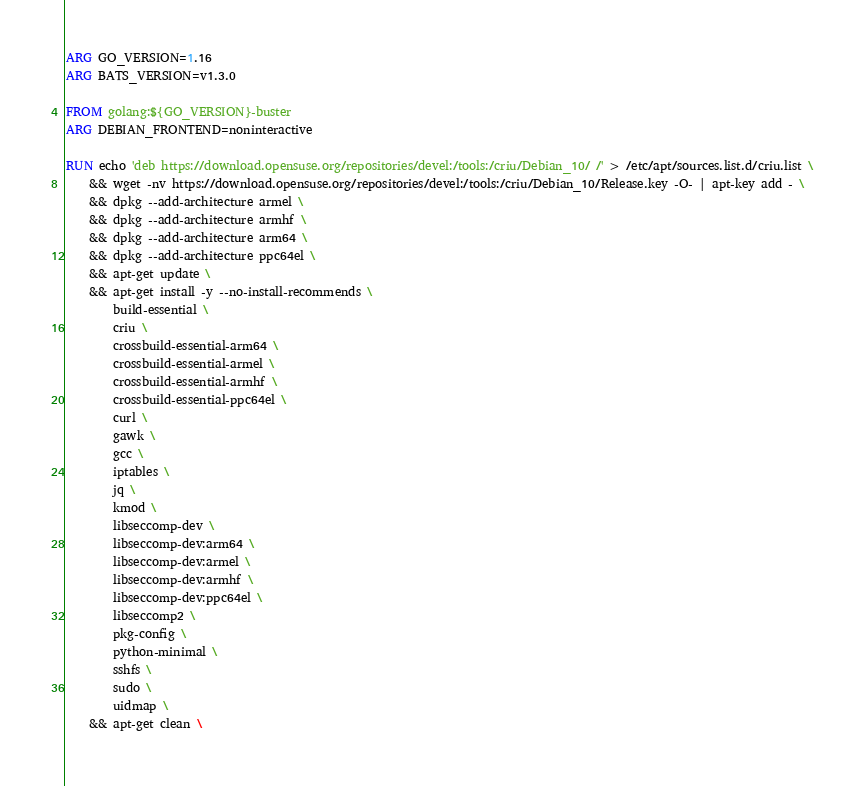<code> <loc_0><loc_0><loc_500><loc_500><_Dockerfile_>ARG GO_VERSION=1.16
ARG BATS_VERSION=v1.3.0

FROM golang:${GO_VERSION}-buster
ARG DEBIAN_FRONTEND=noninteractive

RUN echo 'deb https://download.opensuse.org/repositories/devel:/tools:/criu/Debian_10/ /' > /etc/apt/sources.list.d/criu.list \
    && wget -nv https://download.opensuse.org/repositories/devel:/tools:/criu/Debian_10/Release.key -O- | apt-key add - \
    && dpkg --add-architecture armel \
    && dpkg --add-architecture armhf \
    && dpkg --add-architecture arm64 \
    && dpkg --add-architecture ppc64el \
    && apt-get update \
    && apt-get install -y --no-install-recommends \
        build-essential \
        criu \
        crossbuild-essential-arm64 \
        crossbuild-essential-armel \
        crossbuild-essential-armhf \
        crossbuild-essential-ppc64el \
        curl \
        gawk \
        gcc \
        iptables \
        jq \
        kmod \
        libseccomp-dev \
        libseccomp-dev:arm64 \
        libseccomp-dev:armel \
        libseccomp-dev:armhf \
        libseccomp-dev:ppc64el \
        libseccomp2 \
        pkg-config \
        python-minimal \
        sshfs \
        sudo \
        uidmap \
    && apt-get clean \</code> 